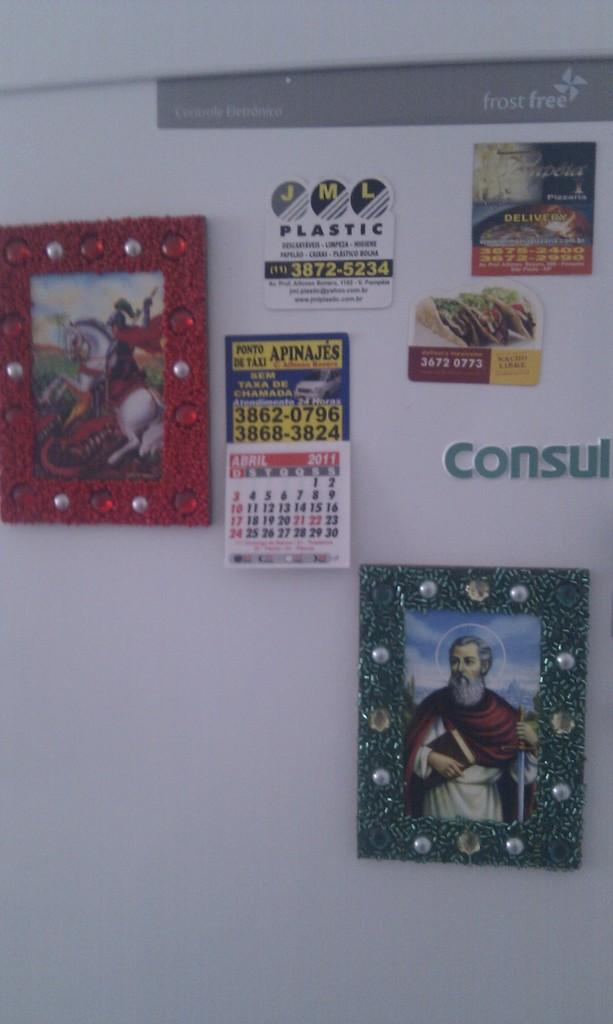What objects in the image are used for displaying pictures? There are photo frames in the image. What object in the image is used for tracking dates and appointments? There is a calendar in the image. What can be seen on the white wall in the image? There is text on a white wall in the image. What type of cat is sitting on the calendar in the image? There is no cat present in the image; it only features photo frames, a calendar, and text on a white wall. What meal is being prepared in the image? There is no meal preparation visible in the image. 